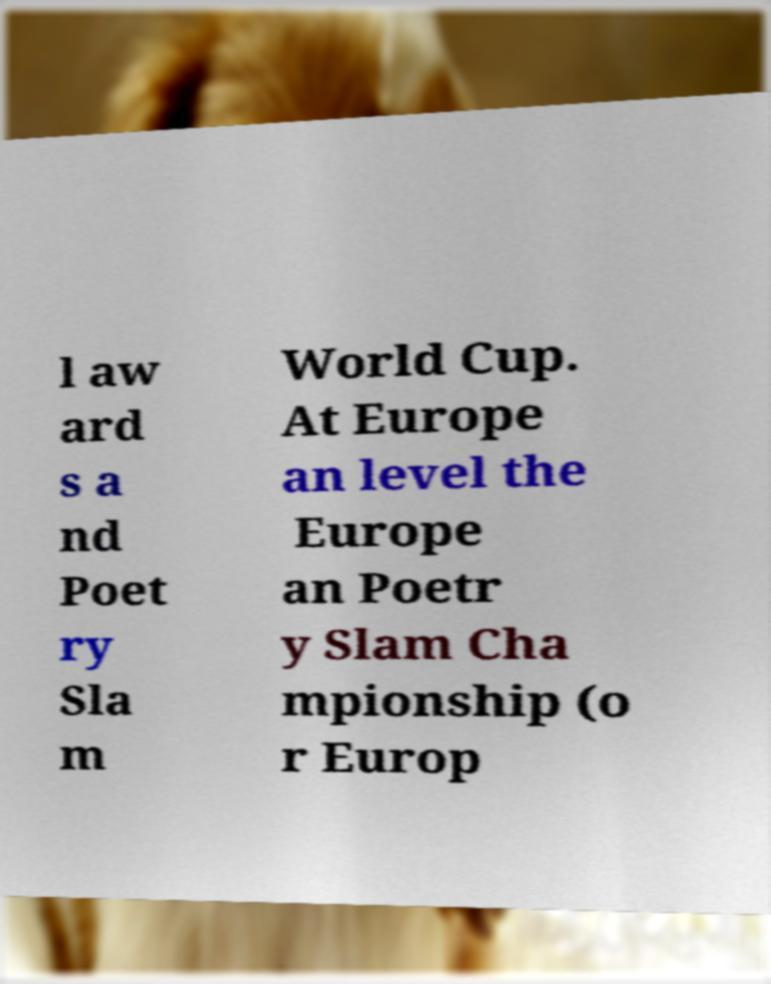Please read and relay the text visible in this image. What does it say? l aw ard s a nd Poet ry Sla m World Cup. At Europe an level the Europe an Poetr y Slam Cha mpionship (o r Europ 